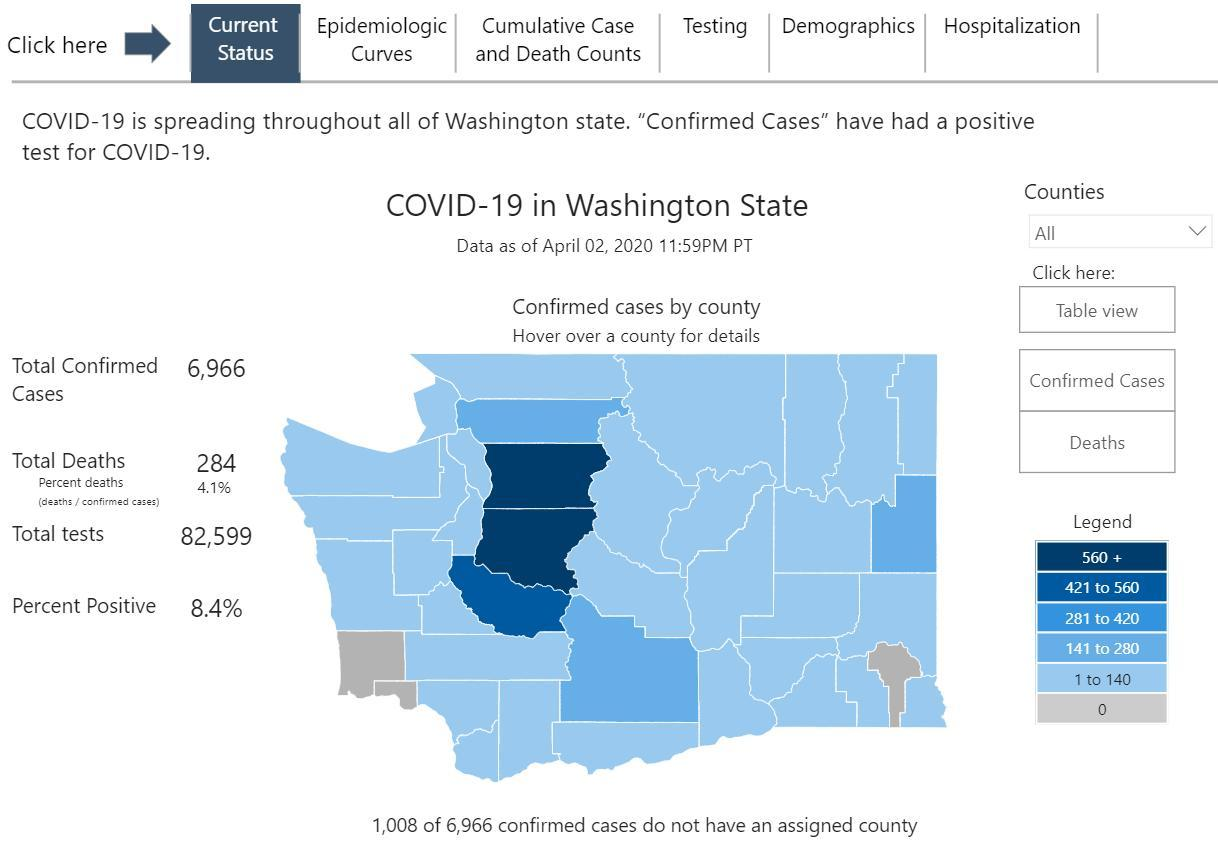What is the confirmed case count in Pierce
Answer the question with a short phrase. 421 to 560 What is the confirmed case count in Pacific 0 What is the confirmed case count in Spokane 141-280 What is the confirmed case count in Snohomish 560 + In which range is the count in most of the counties 1 to 140 